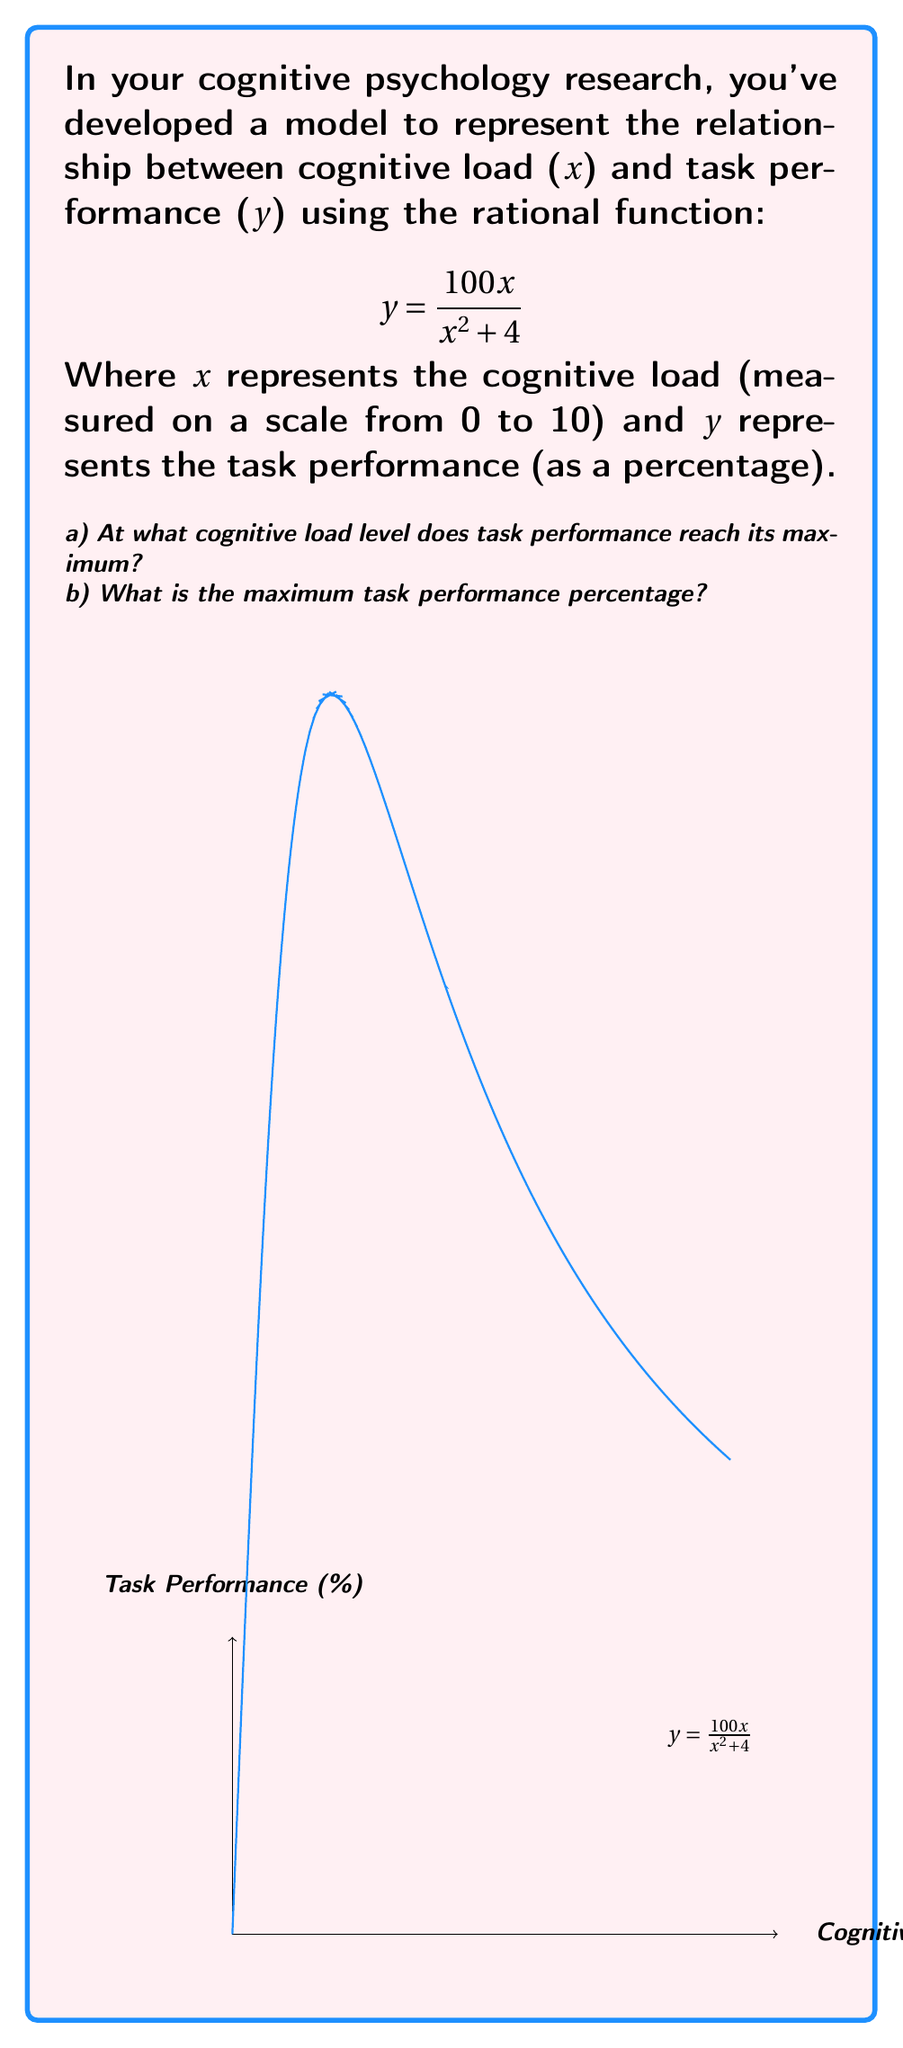Show me your answer to this math problem. Let's approach this step-by-step:

1) To find the maximum point, we need to find where the derivative of the function equals zero.

2) Let's start by finding the derivative using the quotient rule:
   $$ y' = \frac{(x^2+4)(100) - 100x(2x)}{(x^2+4)^2} = \frac{100(x^2+4) - 200x^2}{(x^2+4)^2} = \frac{100(4-x^2)}{(x^2+4)^2} $$

3) Set this equal to zero and solve:
   $$ \frac{100(4-x^2)}{(x^2+4)^2} = 0 $$
   
   The numerator must be zero (the denominator is always positive):
   $$ 4-x^2 = 0 $$
   $$ x^2 = 4 $$
   $$ x = \pm 2 $$

4) Since cognitive load is measured from 0 to 10, x = 2 is our solution.

5) To find the maximum performance, we plug x = 2 into our original function:
   $$ y = \frac{100(2)}{2^2 + 4} = \frac{200}{8} = 25 $$

Therefore, the maximum task performance is 25%.
Answer: a) 2
b) 25% 